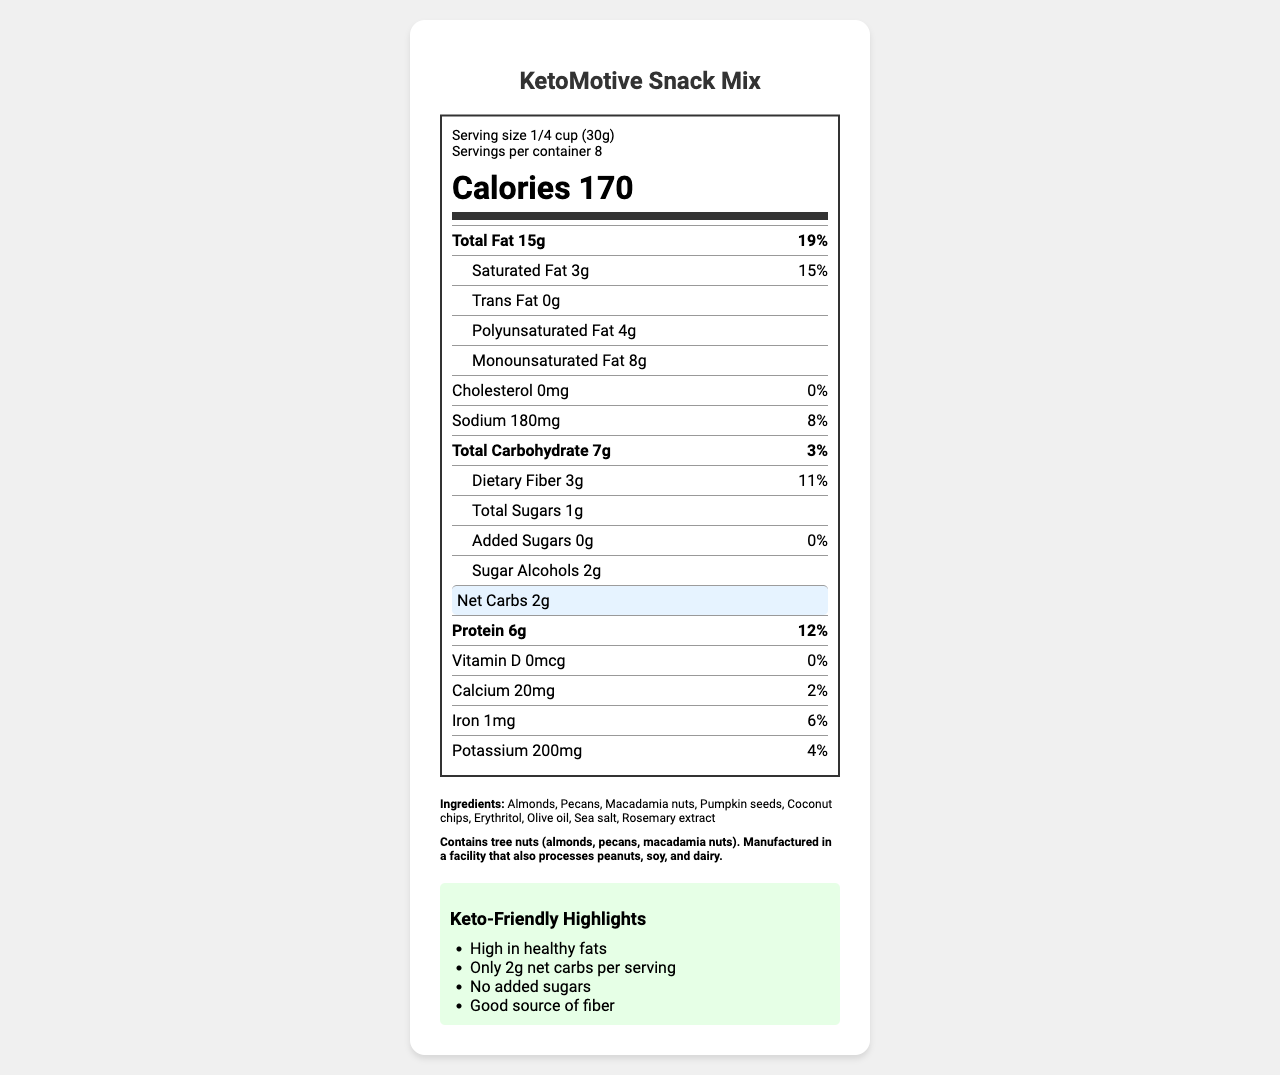what is the serving size for KetoMotive Snack Mix? The serving size is listed at the beginning of the Nutrition Facts, directly under the product name and just above the calories section.
Answer: 1/4 cup (30g) how many calories are in one serving? The calories per serving are displayed prominently in large font in the middle of the Nutrition Facts label.
Answer: 170 what is the total fat amount per serving? The total fat amount is listed right below the calories section, as "Total Fat 15g".
Answer: 15g what is the net carb content per serving? The net carbs are highlighted in a special section within the Nutrition Facts label, making it easy to spot.
Answer: 2g how much protein does one serving contain? The protein amount is labeled in bold text towards the bottom of the Nutrition Facts label.
Answer: 6g which fats are included in the KetoMotive Snack Mix, and in what amounts? A. Polyunsaturated Fat (4g), Monounsaturated Fat (8g) B. Polyunsaturated Fat (8g), Monounsaturated Fat (4g) C. Polyunsaturated Fat (6g), Monounsaturated Fat (6g) The label lists Polyunsaturated Fat as 4g and Monounsaturated Fat as 8g under the sub-nutrient section for Total Fat.
Answer: A what is the daily value percentage for saturated fat? A. 10% B. 15% C. 20% The daily value percentage for Saturated Fat is 15%, as indicated next to the amount in the total fat section.
Answer: B does the KetoMotive Snack Mix contain any added sugars? The document specifies that there are 0g of added sugars, which is also noted with a daily value of 0%.
Answer: No is the KetoMotive Snack Mix keto-friendly? The Keto-Friendly Highlights section clearly states attributes that make this snack mix keto-friendly, such as "Only 2g net carbs per serving" and "No added sugars."
Answer: Yes what are the main allergens present in this snack mix? The allergen info section at the bottom specifies that the snack mix contains tree nuts, including almonds, pecans, and macadamia nuts.
Answer: Tree nuts (almonds, pecans, macadamia nuts) describe the key nutritional features and design considerations of the KetoMotive Snack Mix label. This summary describes the main nutritional elements and design aspects of the label, providing an overall view of its content and usability features.
Answer: The KetoMotive Snack Mix nutrition label features a concise overview of the product's nutritional content, including a serving size of 1/4 cup (30g) and 170 calories per serving. It highlights key attributes like high fat content (15g total fat) and low net carbs (2g). The label also specifies the absence of added sugars. It incorporates user-friendly design elements such as a clean font, highlighting of net carbs, and macronutrient ratios. Accessibility features include high color contrast and screen-reader compatibility. what is the main source of healthy fats in this snack mix? The document lists various ingredients with healthy fats like almonds, pecans, macadamia nuts, and olive oil, but it does not specify which one is the main source.
Answer: Cannot be determined what visual design features are used to make the label more readable? These features are highlighted in the "UI Design Considerations" section to ensure the label is clear and readable.
Answer: Use of a clean, easy-to-read font, highlighting net carbs and healthy fats with contrasting colors, and adding a visual representation of macronutrient ratios are some design considerations mentioned in the document. how many grams of dietary fiber are in one serving, and what percentage of the daily value does this represent? The dietary fiber section in the Nutrition Facts label indicates 3g and represents 11% of the daily value.
Answer: 3g, 11% 